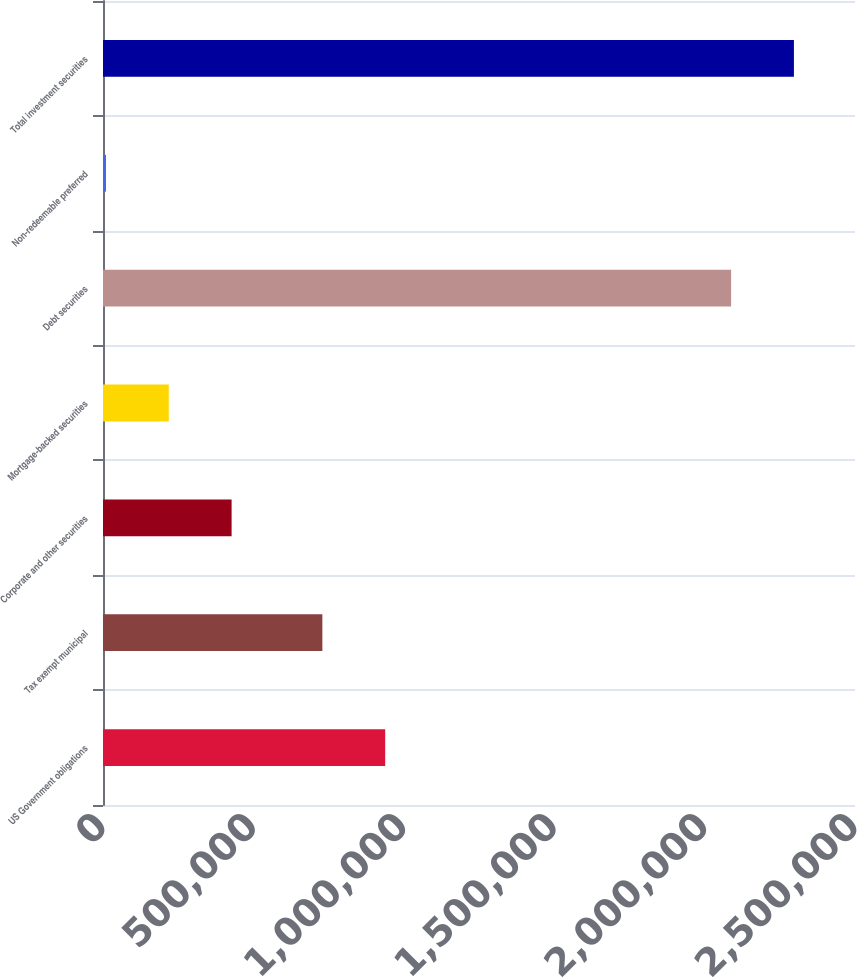Convert chart to OTSL. <chart><loc_0><loc_0><loc_500><loc_500><bar_chart><fcel>US Government obligations<fcel>Tax exempt municipal<fcel>Corporate and other securities<fcel>Mortgage-backed securities<fcel>Debt securities<fcel>Non-redeemable preferred<fcel>Total investment securities<nl><fcel>938113<fcel>729302<fcel>427509<fcel>218697<fcel>2.08811e+06<fcel>9886<fcel>2.29692e+06<nl></chart> 